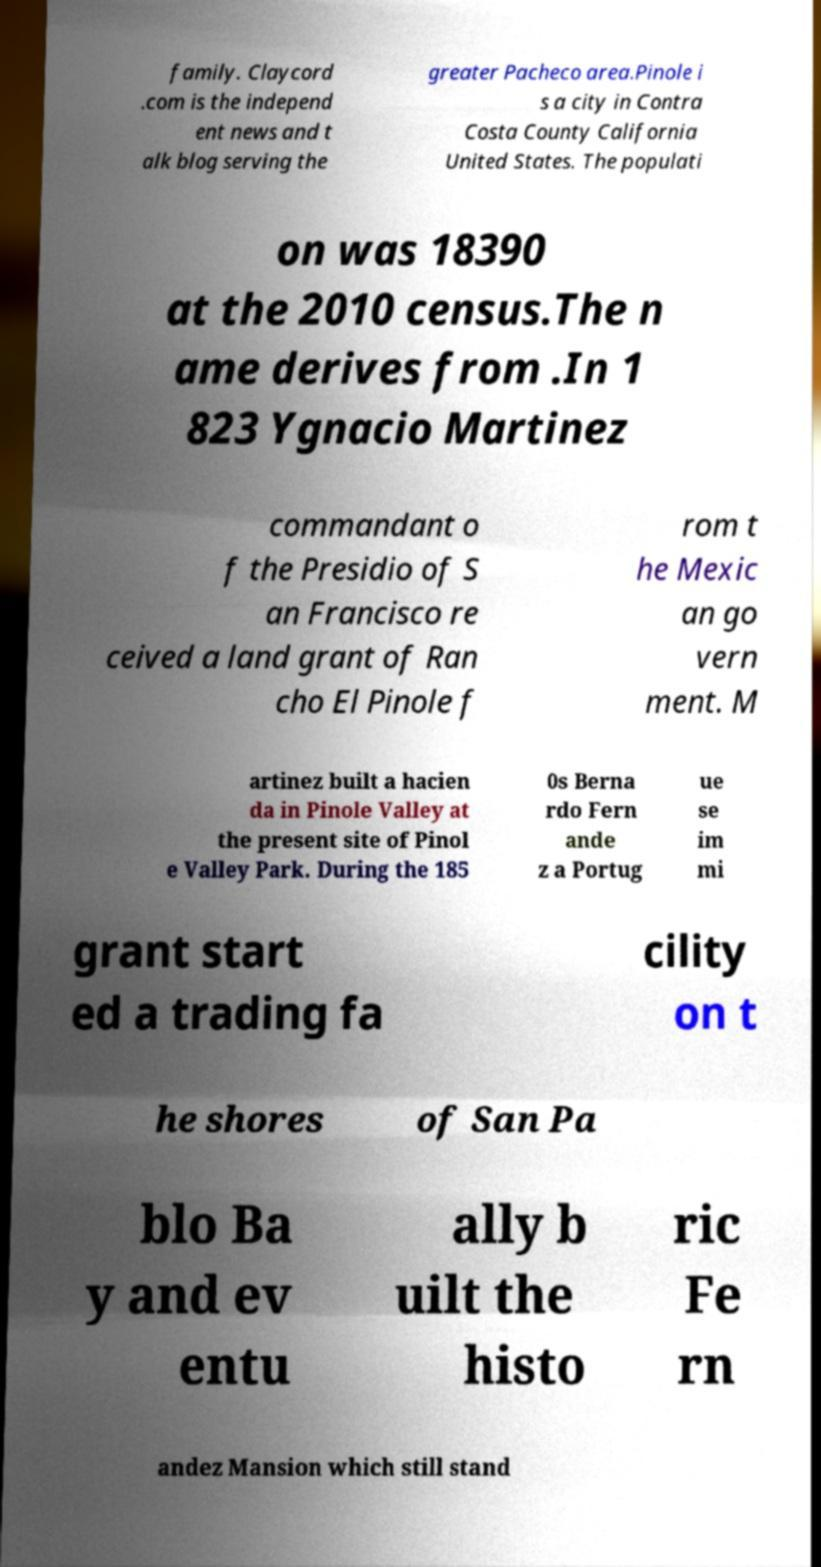Can you accurately transcribe the text from the provided image for me? family. Claycord .com is the independ ent news and t alk blog serving the greater Pacheco area.Pinole i s a city in Contra Costa County California United States. The populati on was 18390 at the 2010 census.The n ame derives from .In 1 823 Ygnacio Martinez commandant o f the Presidio of S an Francisco re ceived a land grant of Ran cho El Pinole f rom t he Mexic an go vern ment. M artinez built a hacien da in Pinole Valley at the present site of Pinol e Valley Park. During the 185 0s Berna rdo Fern ande z a Portug ue se im mi grant start ed a trading fa cility on t he shores of San Pa blo Ba y and ev entu ally b uilt the histo ric Fe rn andez Mansion which still stand 